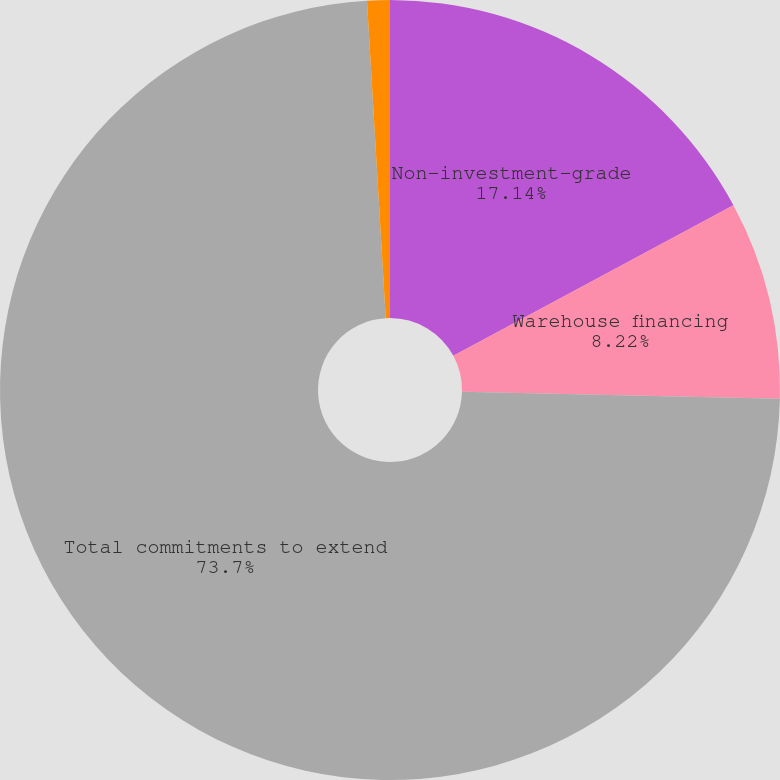Convert chart to OTSL. <chart><loc_0><loc_0><loc_500><loc_500><pie_chart><fcel>Non-investment-grade<fcel>Warehouse financing<fcel>Total commitments to extend<fcel>Investment commitments<nl><fcel>17.14%<fcel>8.22%<fcel>73.7%<fcel>0.94%<nl></chart> 